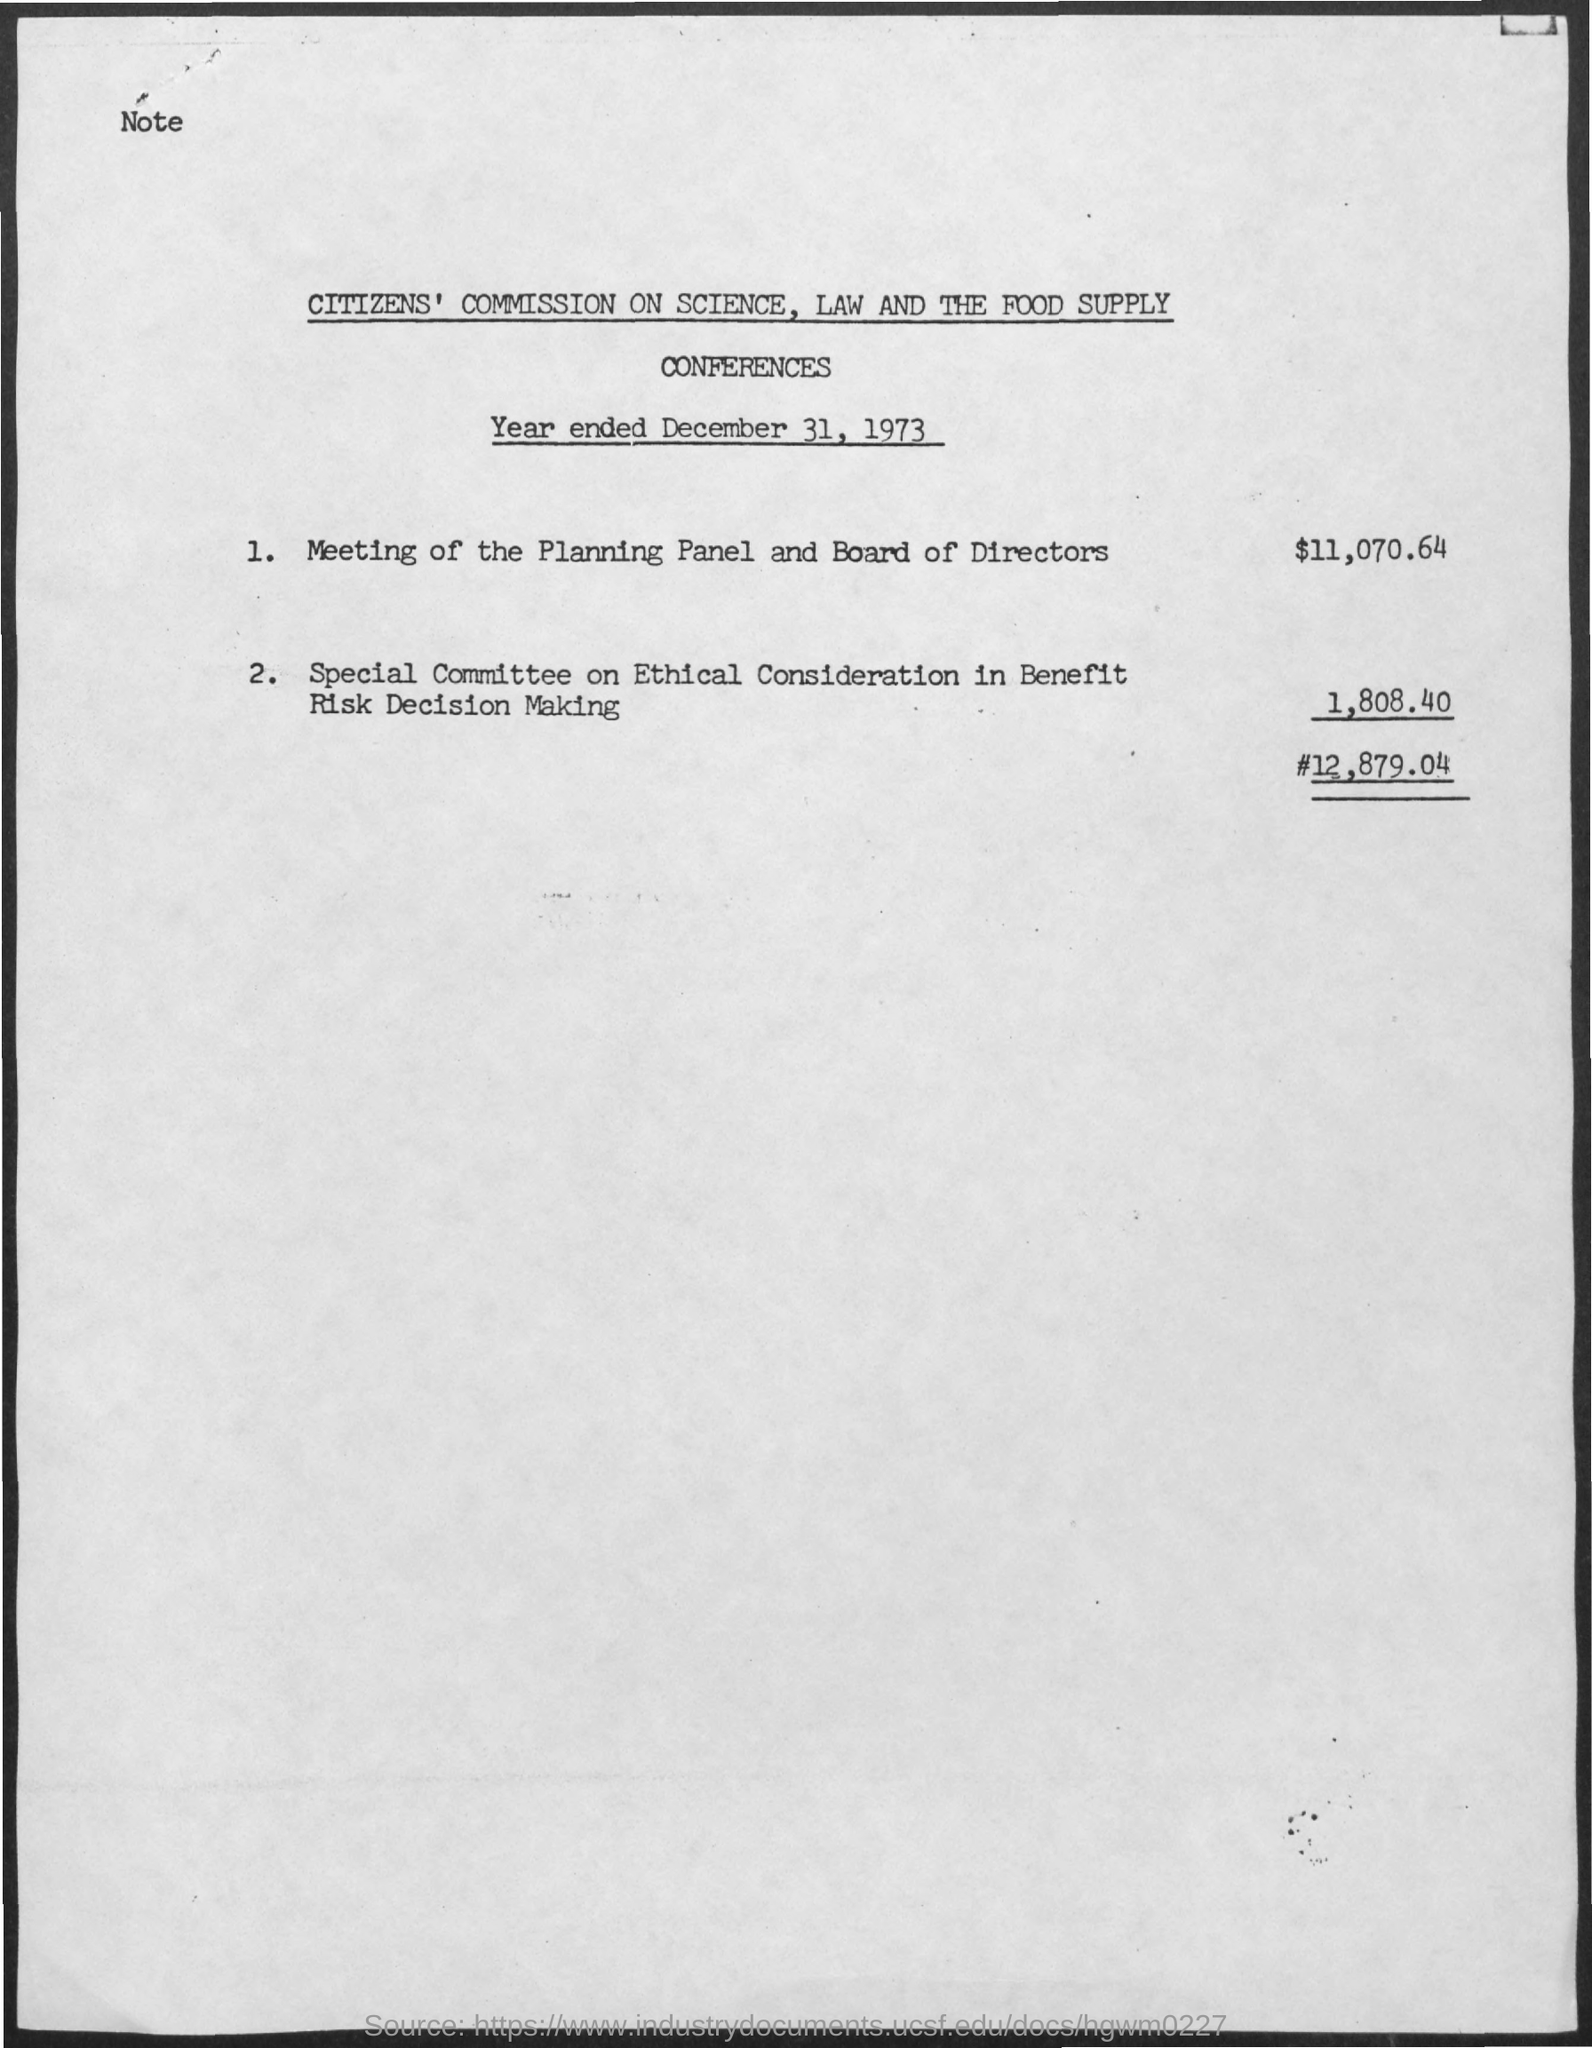What is the date on the document?
Offer a very short reply. December 31, 1973. What is the amount for meeting of the planning panel and board of directors?
Your answer should be compact. $11,070.64. What is the amount for special committee on ethical consideration in benefit risk decision making?
Your answer should be very brief. 1,808.40. 